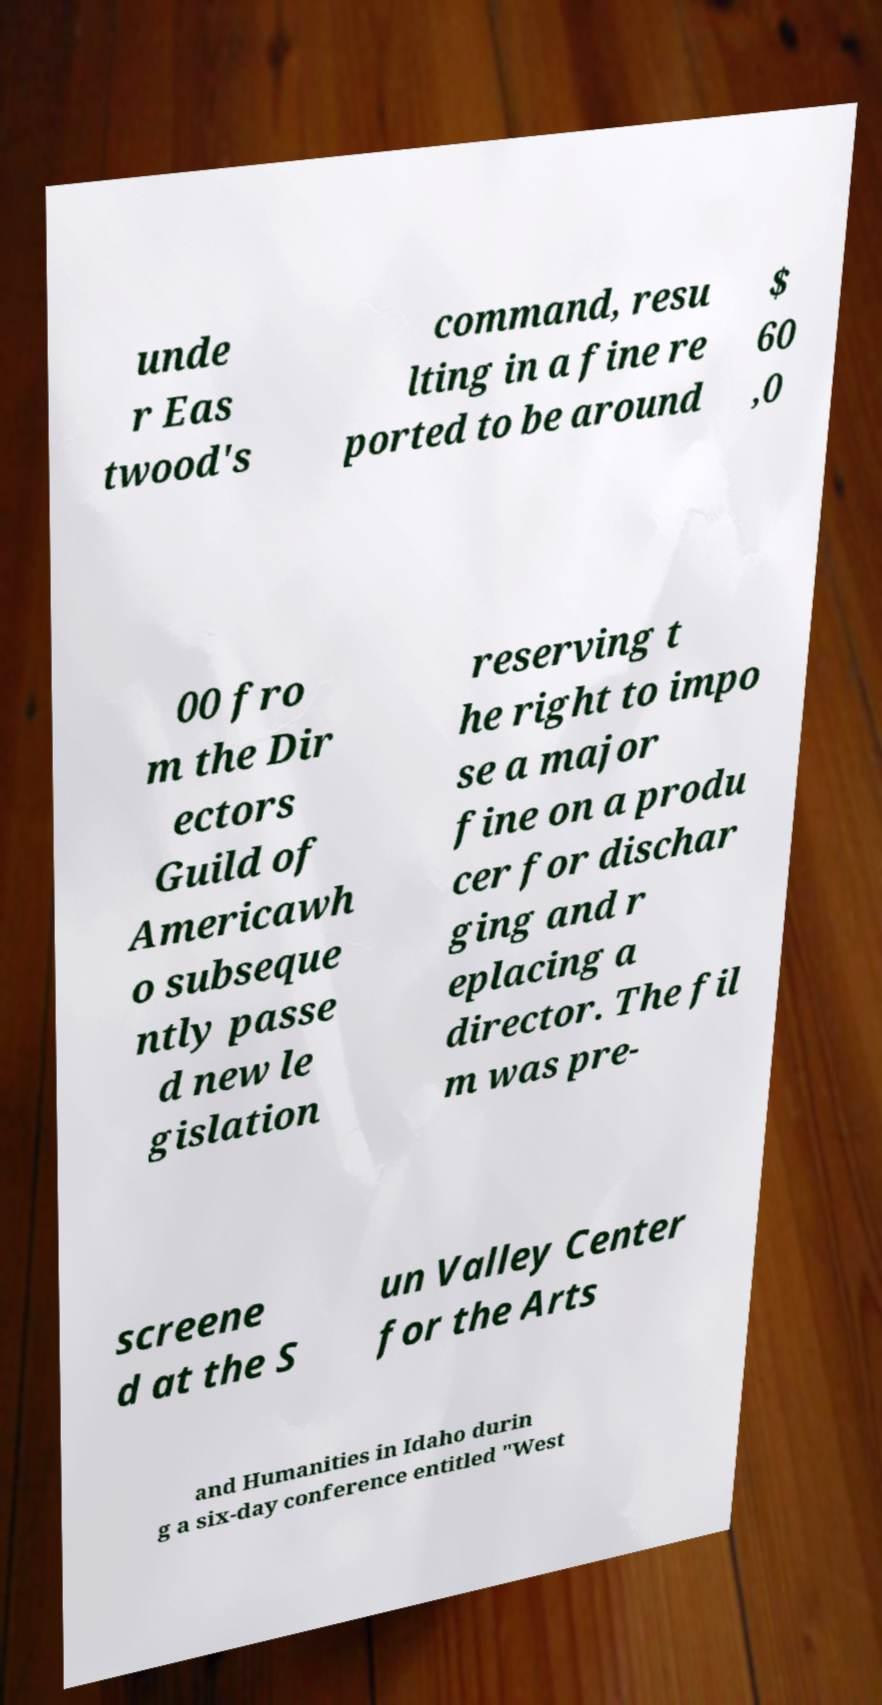What messages or text are displayed in this image? I need them in a readable, typed format. unde r Eas twood's command, resu lting in a fine re ported to be around $ 60 ,0 00 fro m the Dir ectors Guild of Americawh o subseque ntly passe d new le gislation reserving t he right to impo se a major fine on a produ cer for dischar ging and r eplacing a director. The fil m was pre- screene d at the S un Valley Center for the Arts and Humanities in Idaho durin g a six-day conference entitled "West 